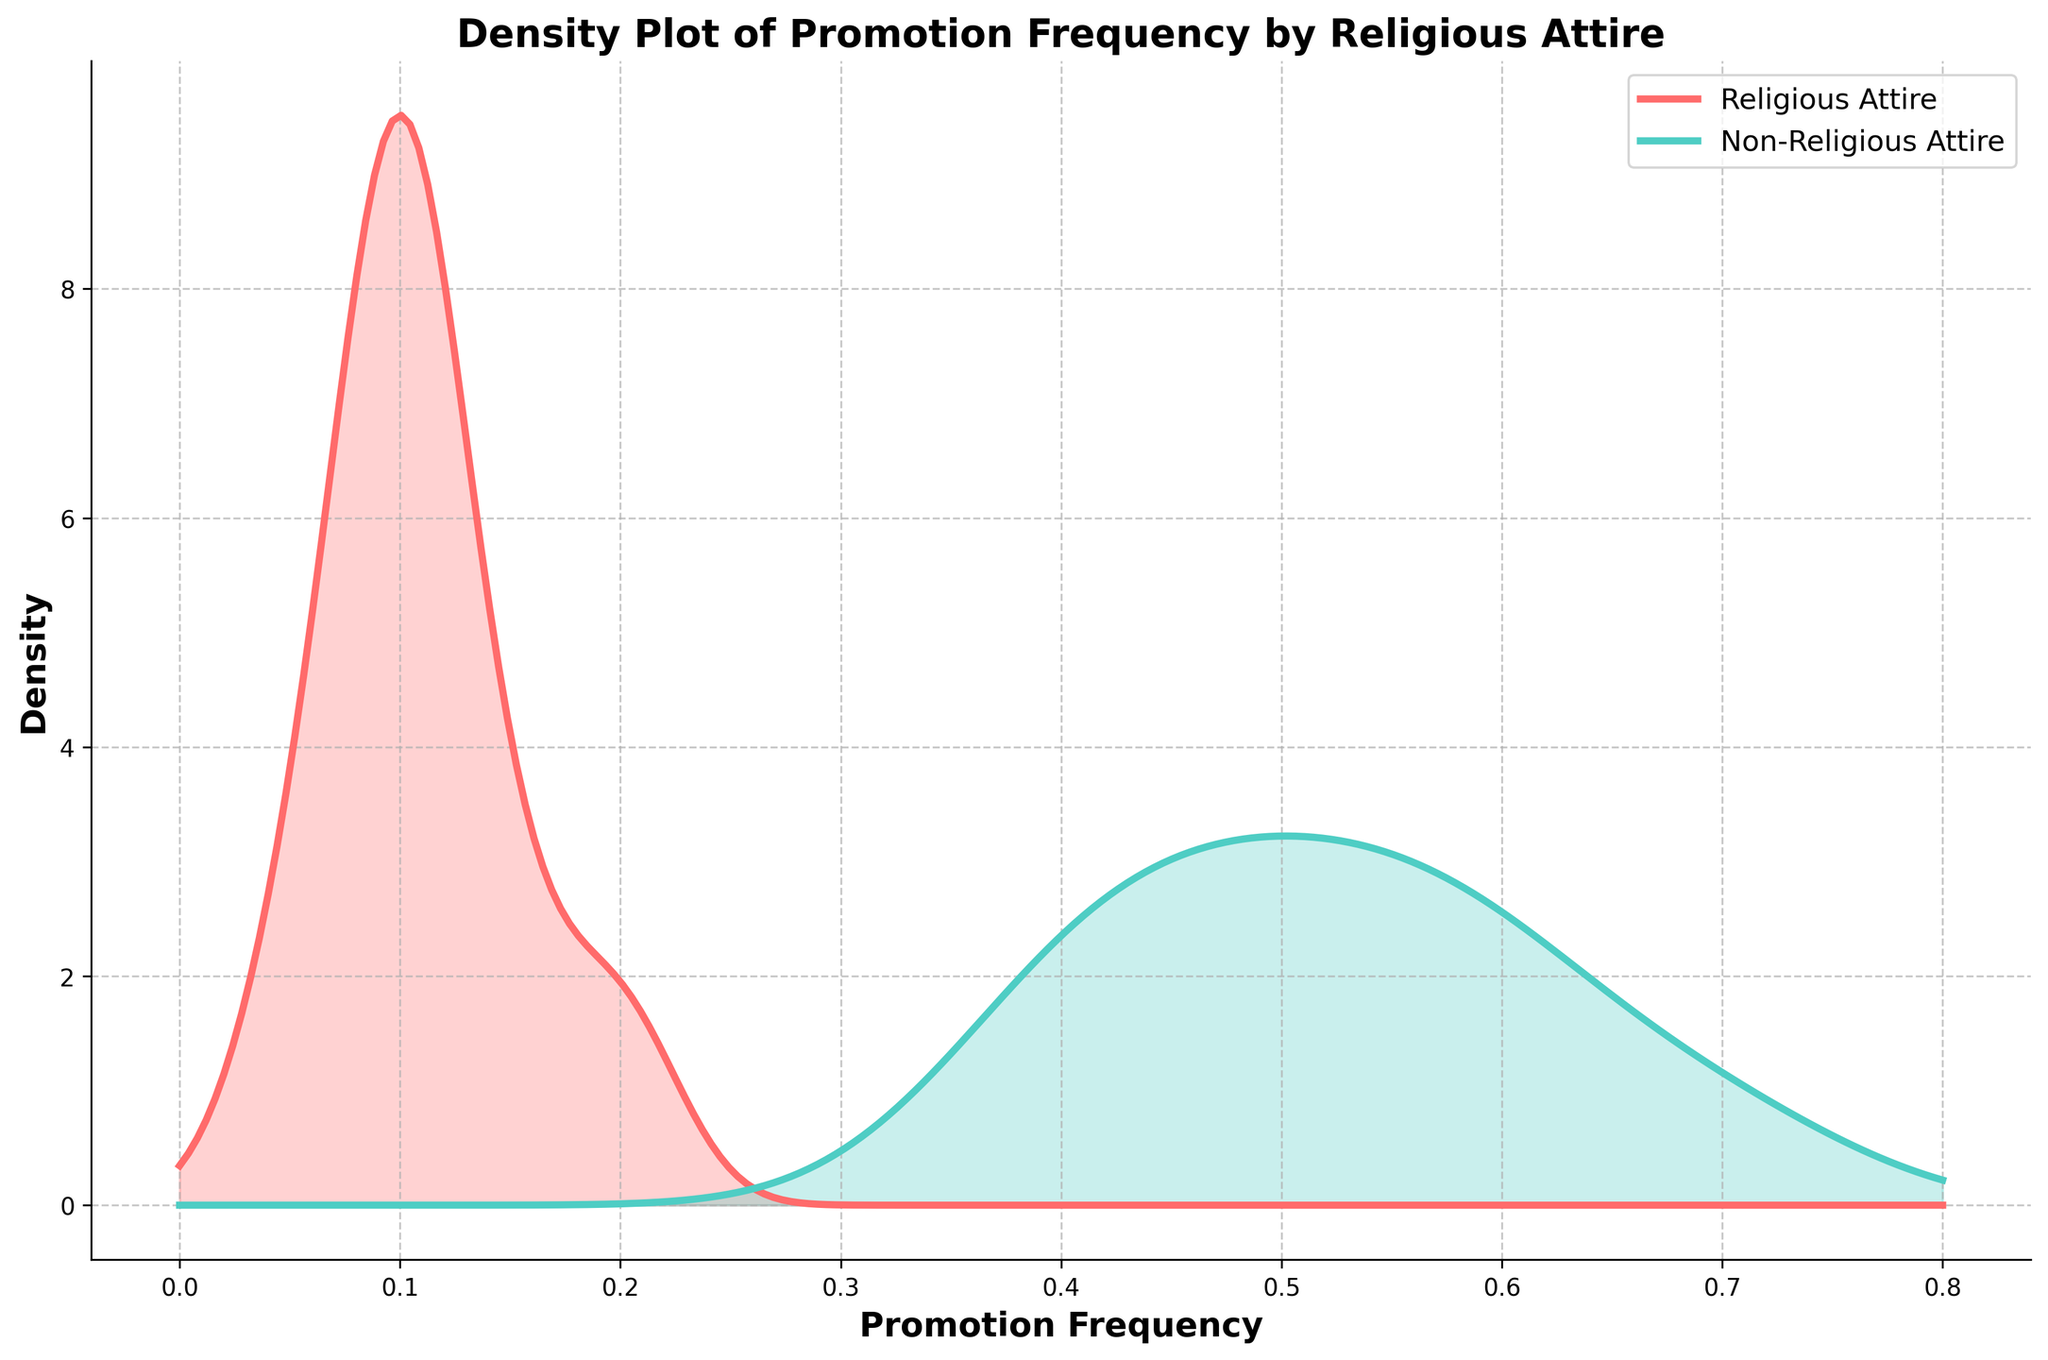What is the title of the plot? The title of the plot is displayed at the top of the figure. It summarizes the main focus of the visual. The title is "Density Plot of Promotion Frequency by Religious Attire"
Answer: "Density Plot of Promotion Frequency by Religious Attire" Which color represents individuals wearing religious attire? Colors are used to differentiate between groups in the plot. The plot has a legend indicating that the color red represents individuals wearing religious attire.
Answer: Red What is the x-axis label of the plot? The x-axis label is shown at the bottom of the horizontal axis, describing what the axis represents. It shows "Promotion Frequency."
Answer: "Promotion Frequency" What group has the higher density peak in the plot? The density peak is the point on the plot where the distribution reaches its highest value. The plot shows that individuals not wearing religious attire have a higher density peak with the blue line.
Answer: Individuals not wearing religious attire At approximately what value of promotion frequency does the peak density occur for individuals not wearing religious attire? To find this, look for the highest point on the blue density line and identify the corresponding value on the x-axis. The peak density for individuals not wearing religious attire occurs around a promotion frequency of 0.6.
Answer: 0.6 Compare the spread of the distributions for individuals wearing religious attire with those not wearing religious attire. To compare the spread, note how wide each density curve is. The red density curve (wearing religious attire) is more spread out compared to the blue curve (not wearing religious attire), indicating a wider range of promotion frequencies.
Answer: The red curve is more spread out What is the y-axis label of the plot? The y-axis label is displayed along the vertical axis, describing what is measured. The plot shows "Density" as the y-axis label.
Answer: "Density" Which group has a more frequent lower promotion rate? Observe where the density of each group is concentrated. The red curve indicates that individuals wearing religious attire have more density at lower promotion frequencies, meaning this group experiences lower promotion rates more frequently.
Answer: Individuals wearing religious attire Towards what value do both density lines diminish to nearly zero? Follow both density curves towards the tails to see where they approach zero density. Both density lines diminish to nearly zero at promotion frequencies around 0.8.
Answer: 0.8 